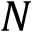Convert formula to latex. <formula><loc_0><loc_0><loc_500><loc_500>N</formula> 